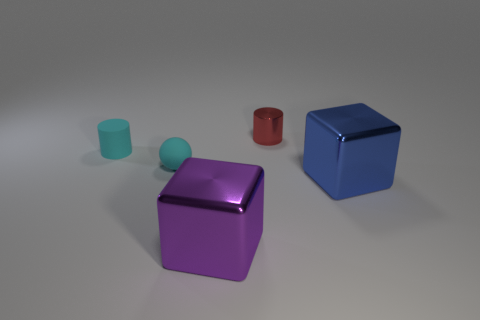Add 2 large cyan cubes. How many objects exist? 7 Subtract all spheres. How many objects are left? 4 Add 3 spheres. How many spheres exist? 4 Subtract 0 gray spheres. How many objects are left? 5 Subtract all tiny red metal objects. Subtract all blue shiny cubes. How many objects are left? 3 Add 1 big cubes. How many big cubes are left? 3 